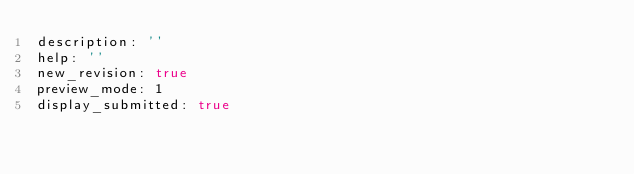<code> <loc_0><loc_0><loc_500><loc_500><_YAML_>description: ''
help: ''
new_revision: true
preview_mode: 1
display_submitted: true
</code> 